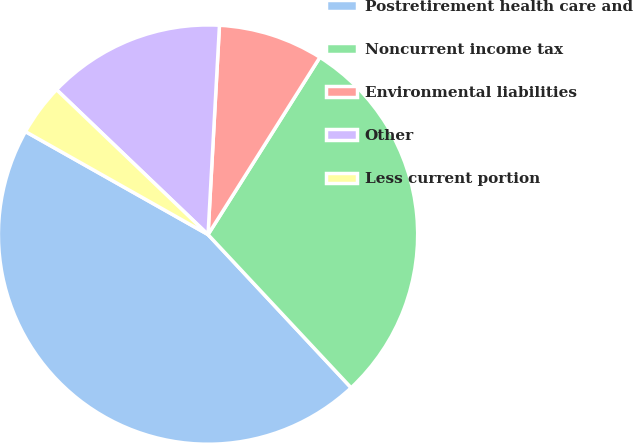<chart> <loc_0><loc_0><loc_500><loc_500><pie_chart><fcel>Postretirement health care and<fcel>Noncurrent income tax<fcel>Environmental liabilities<fcel>Other<fcel>Less current portion<nl><fcel>45.13%<fcel>29.08%<fcel>8.09%<fcel>13.72%<fcel>3.97%<nl></chart> 